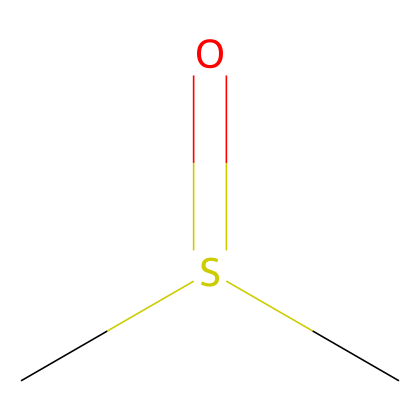How many carbon atoms are present in this compound? The SMILES representation shows two carbon atoms ('C') at the beginning, indicating there are two carbon atoms in the structure.
Answer: 2 What functional group is present in dimethyl sulfoxide? The 'S(=O)' part of the SMILES indicates that a sulfur atom is bonded to an oxygen atom with a double bond, representing the sulfoxide functional group.
Answer: sulfoxide How many hydrogen atoms are associated with the carbon atoms in this structure? Each carbon atom is generally bonded to three hydrogen atoms; since there are two carbon atoms, and we account for the carbon-sulfur linkage, a total of six - two from each carbon. However, one hydrogen is lost in the bond to sulfur, leading to four hydrogen atoms overall.
Answer: 6 What is the hybridization state of the sulfur atom in dimethyl sulfoxide? The sulfur atom in DMSO is bonded to an oxygen atom through a double bond and to two carbon atoms via single bonds, which requires one p orbital and three sp2 hybrid orbitals to satisfy the bonding needs. This indicates sp2 hybridization.
Answer: sp2 Is dimethyl sulfoxide a polar solvent? The presence of the polar sulfoxide functional group indicates a difference in electronegativity between sulfur and oxygen, resulting in dipole moments that favor polarity.
Answer: yes What type of compound is dimethyl sulfoxide classified as? DMSO is defined as an organosulfur compound due to the presence of sulfur in its molecular structure combined with organic components.
Answer: organosulfur compound 